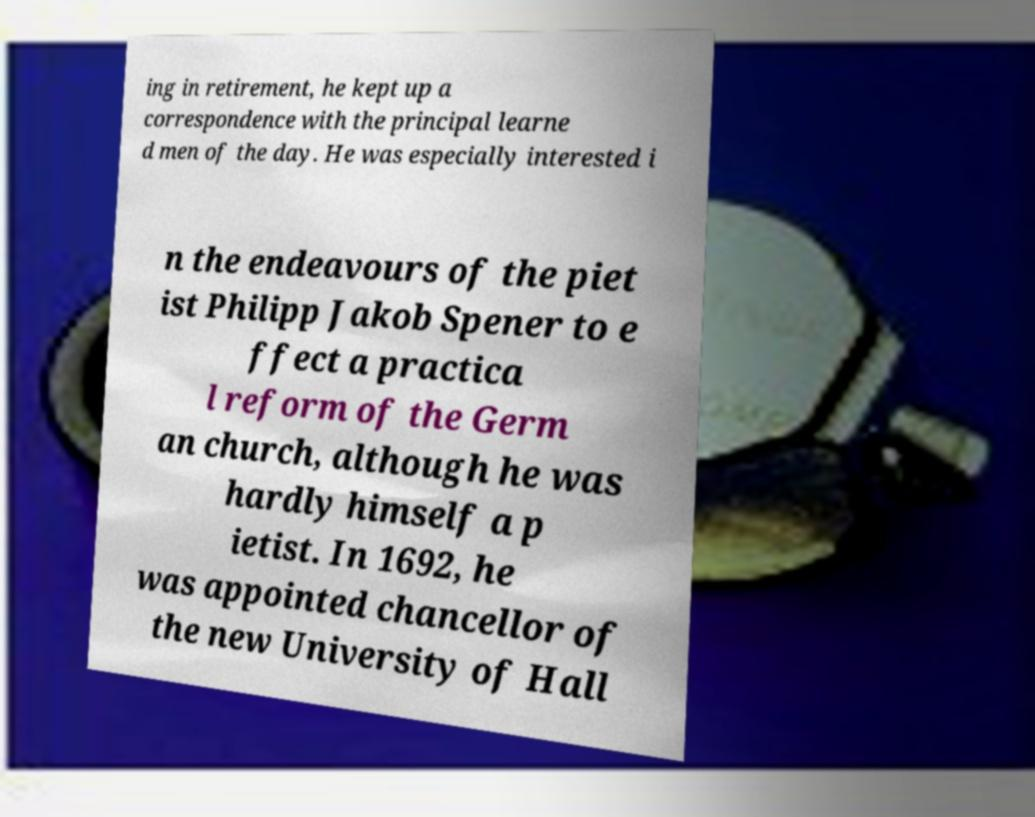What messages or text are displayed in this image? I need them in a readable, typed format. ing in retirement, he kept up a correspondence with the principal learne d men of the day. He was especially interested i n the endeavours of the piet ist Philipp Jakob Spener to e ffect a practica l reform of the Germ an church, although he was hardly himself a p ietist. In 1692, he was appointed chancellor of the new University of Hall 